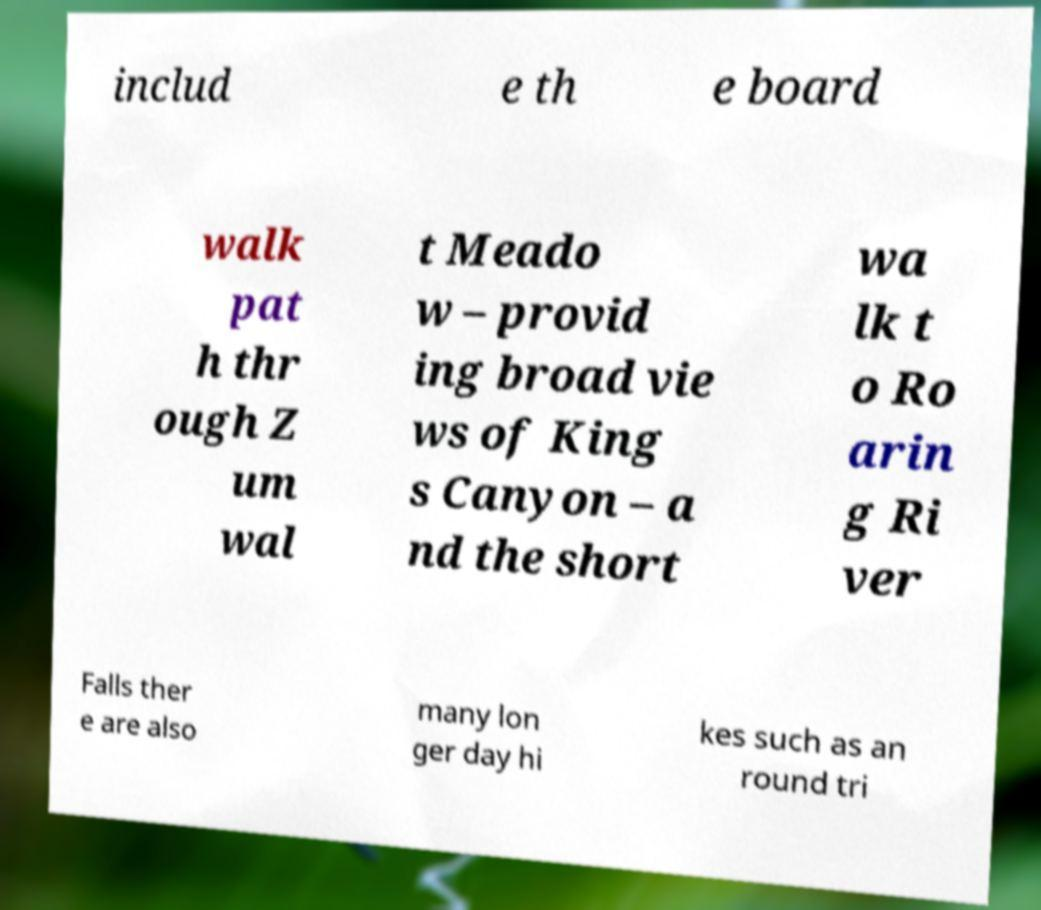There's text embedded in this image that I need extracted. Can you transcribe it verbatim? includ e th e board walk pat h thr ough Z um wal t Meado w – provid ing broad vie ws of King s Canyon – a nd the short wa lk t o Ro arin g Ri ver Falls ther e are also many lon ger day hi kes such as an round tri 